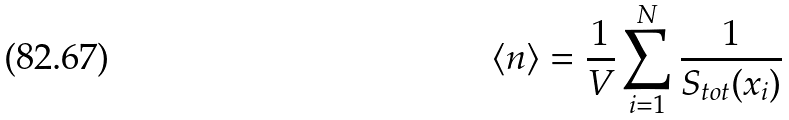<formula> <loc_0><loc_0><loc_500><loc_500>\langle n \rangle = \frac { 1 } { V } \sum _ { i = 1 } ^ { N } \frac { 1 } { S _ { t o t } ( x _ { i } ) }</formula> 